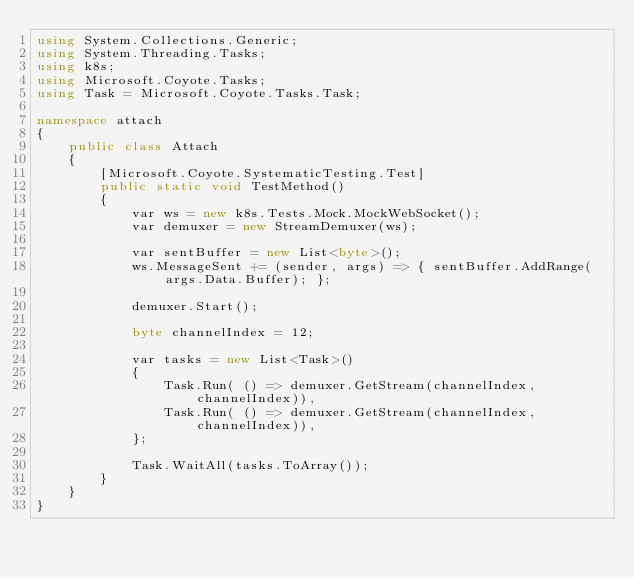<code> <loc_0><loc_0><loc_500><loc_500><_C#_>using System.Collections.Generic;
using System.Threading.Tasks;
using k8s;
using Microsoft.Coyote.Tasks;
using Task = Microsoft.Coyote.Tasks.Task;

namespace attach
{
    public class Attach
    {
        [Microsoft.Coyote.SystematicTesting.Test]
        public static void TestMethod()
        {
            var ws = new k8s.Tests.Mock.MockWebSocket();
            var demuxer = new StreamDemuxer(ws);

            var sentBuffer = new List<byte>();
            ws.MessageSent += (sender, args) => { sentBuffer.AddRange(args.Data.Buffer); };

            demuxer.Start();

            byte channelIndex = 12;

            var tasks = new List<Task>()
            {
                Task.Run( () => demuxer.GetStream(channelIndex, channelIndex)),
                Task.Run( () => demuxer.GetStream(channelIndex, channelIndex)),
            };

            Task.WaitAll(tasks.ToArray());
        }
    }
}
</code> 